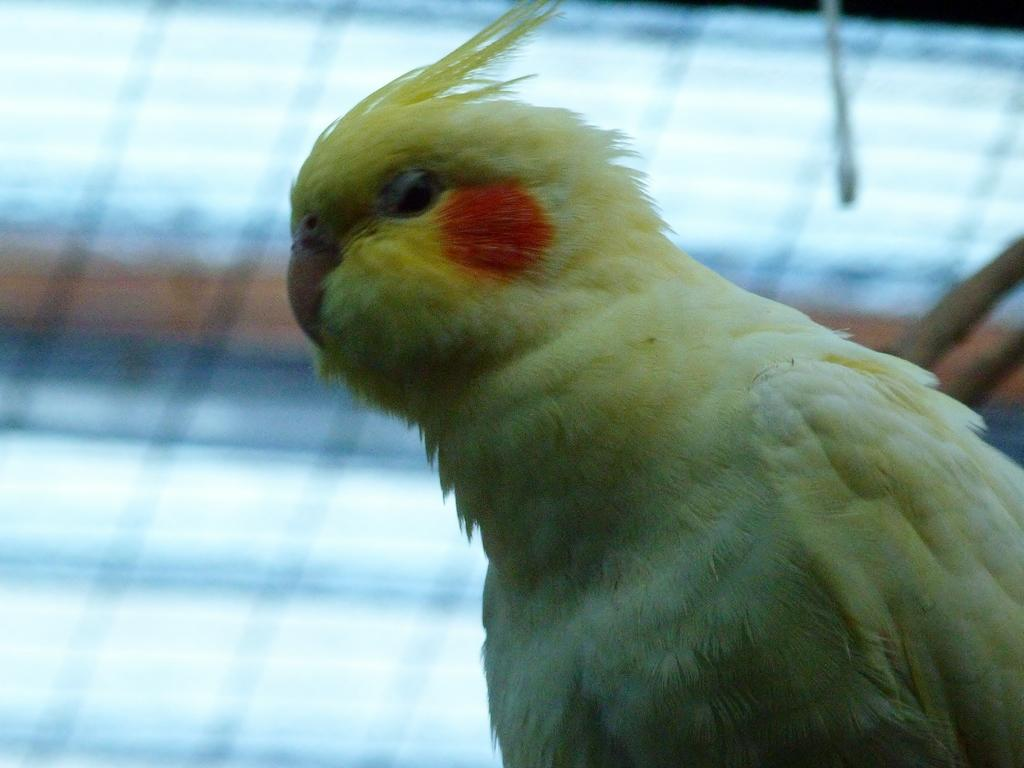What type of animal can be seen on the right side of the image? There is a bird on the right side of the image. What is in the background of the image? There is a net fence in the background of the image. How do the spiders react to the bird in the image? A: There are no spiders present in the image, so it is not possible to determine their reaction to the bird. 